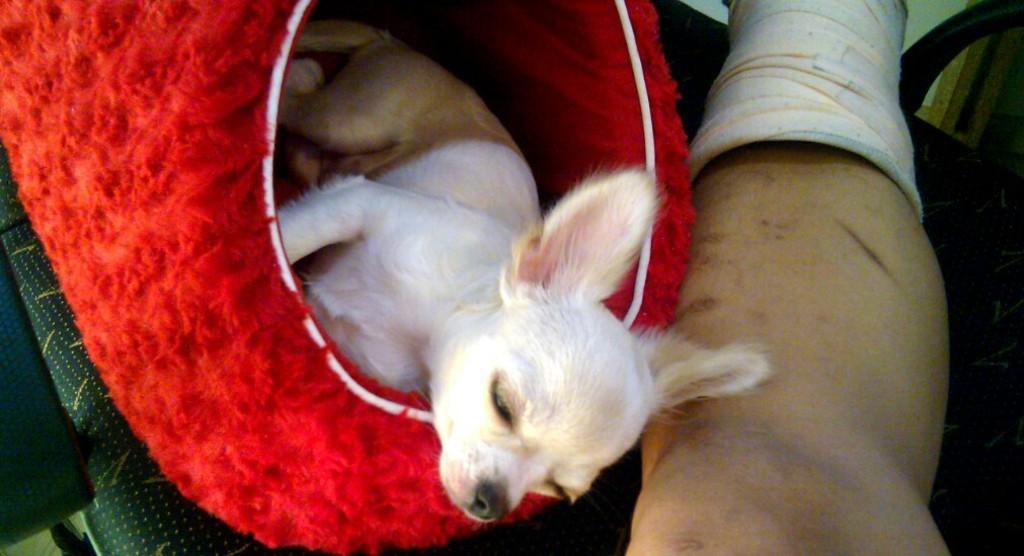Describe this image in one or two sentences. In this picture, we see a dog is in red color bag like. Beside that, we see the leg of the person placed on the black color table. On the left side, we see a green colored cloth. 